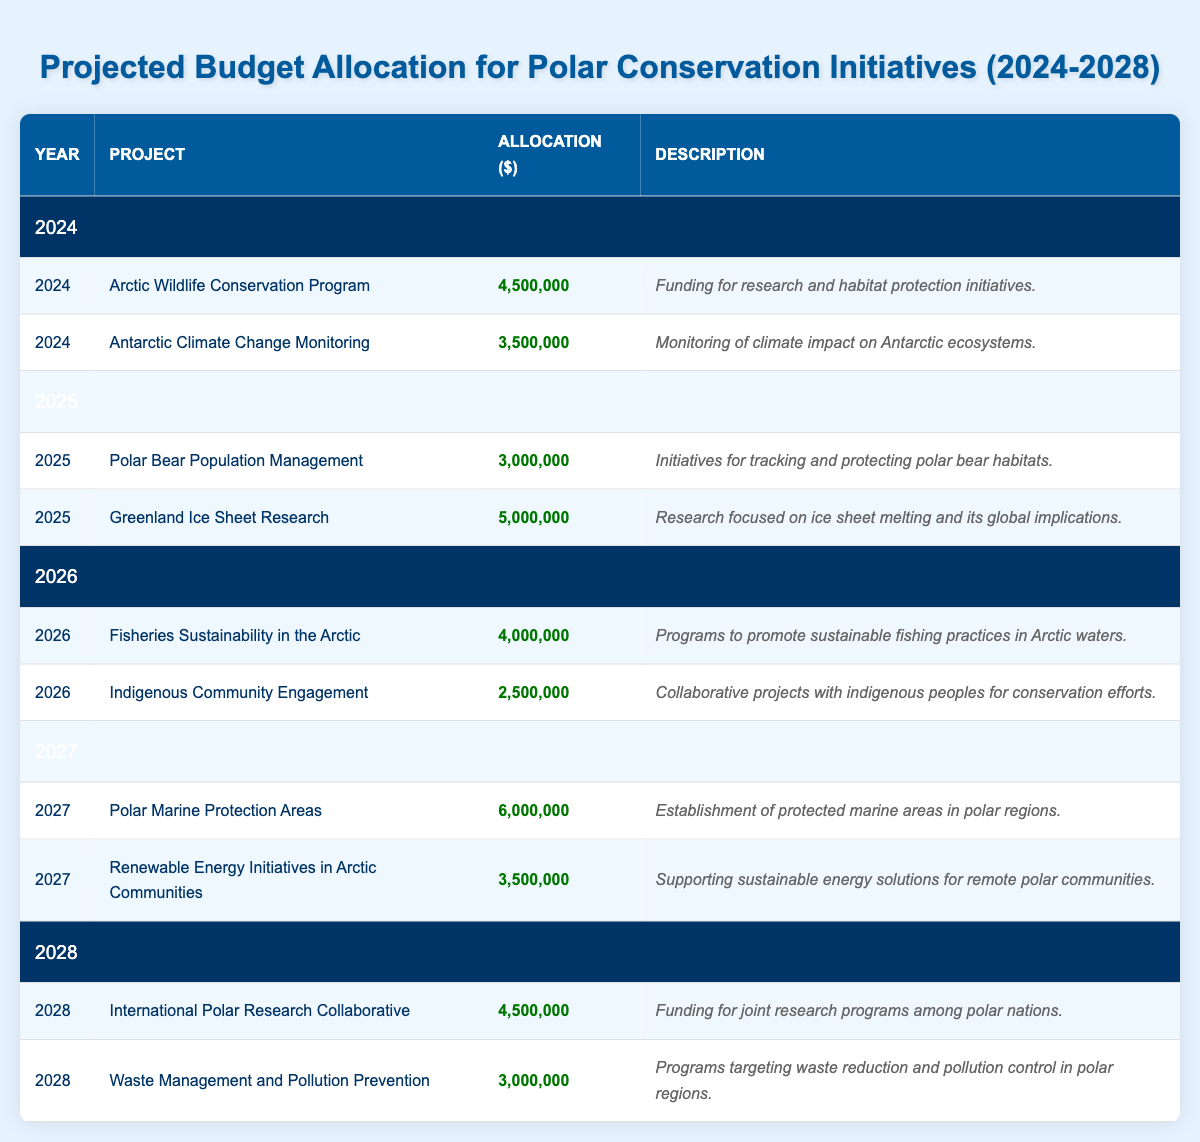What is the total budget allocation for the year 2026? To find the total budget allocation for 2026, we need to add the allocations for both projects listed under that year: Fisheries Sustainability in the Arctic ($4,000,000) and Indigenous Community Engagement ($2,500,000). Performing the addition: 4,000,000 + 2,500,000 = 6,500,000.
Answer: 6,500,000 Which project received the highest allocation in 2027? In 2027, there are two projects listed: Polar Marine Protection Areas with an allocation of $6,000,000 and Renewable Energy Initiatives in Arctic Communities with an allocation of $3,500,000. Comparing the two, Polar Marine Protection Areas received the highest allocation.
Answer: Polar Marine Protection Areas Did any project receive an allocation of $2,000,000 or less in the provided budget? By reviewing all allocation amounts in the table, the smallest allocation is for Indigenous Community Engagement at $2,500,000. Since no amount is $2,000,000 or less, we conclude that no project received that small of an allocation.
Answer: No What is the average allocation for projects in the year 2025? There are two projects in 2025: Polar Bear Population Management ($3,000,000) and Greenland Ice Sheet Research ($5,000,000). To find the average, we first sum the allocations: 3,000,000 + 5,000,000 = 8,000,000. There are 2 projects, so the average is 8,000,000 / 2 = 4,000,000.
Answer: 4,000,000 Is the total allocation for Antarctic initiatives in 2024 greater than that for Arctic initiatives? In 2024, there are two projects. The Antarctic Climate Change Monitoring is allocated $3,500,000, while the Arctic Wildlife Conservation Program is allocated $4,500,000. Comparing these totals: 3,500,000 (Antarctic) < 4,500,000 (Arctic). Therefore, the total allocation for Antarctic initiatives is not greater than that for Arctic initiatives.
Answer: No What is the combined budget for the International Polar Research Collaborative and Waste Management and Pollution Prevention in 2028? In 2028, the International Polar Research Collaborative is allocated $4,500,000 and Waste Management and Pollution Prevention is allocated $3,000,000. Adding these two amounts gives us: 4,500,000 + 3,000,000 = 7,500,000.
Answer: 7,500,000 Which year had the lowest total budget allocation? We need to examine the total allocations for each year: 2024 = 8,000,000, 2025 = 8,000,000, 2026 = 6,500,000, 2027 = 9,500,000, 2028 = 7,500,000. By comparing these totals, we find that 2026 had the lowest allocation.
Answer: 2026 What percentage of the total allocated budget over the five years is assigned to the project focusing on renewable energy? The total budget over the five years is: 4,500,000 + 3,500,000 + 3,000,000 + 5,000,000 + 4,000,000 + 2,500,000 + 6,000,000 + 3,500,000 + 4,500,000 + 3,000,000 = 43,000,000. The Renewable Energy Initiatives in Arctic Communities is allocated $3,500,000. To find the percentage: (3,500,000 / 43,000,000) * 100 = approximately 8.14%.
Answer: 8.14% 